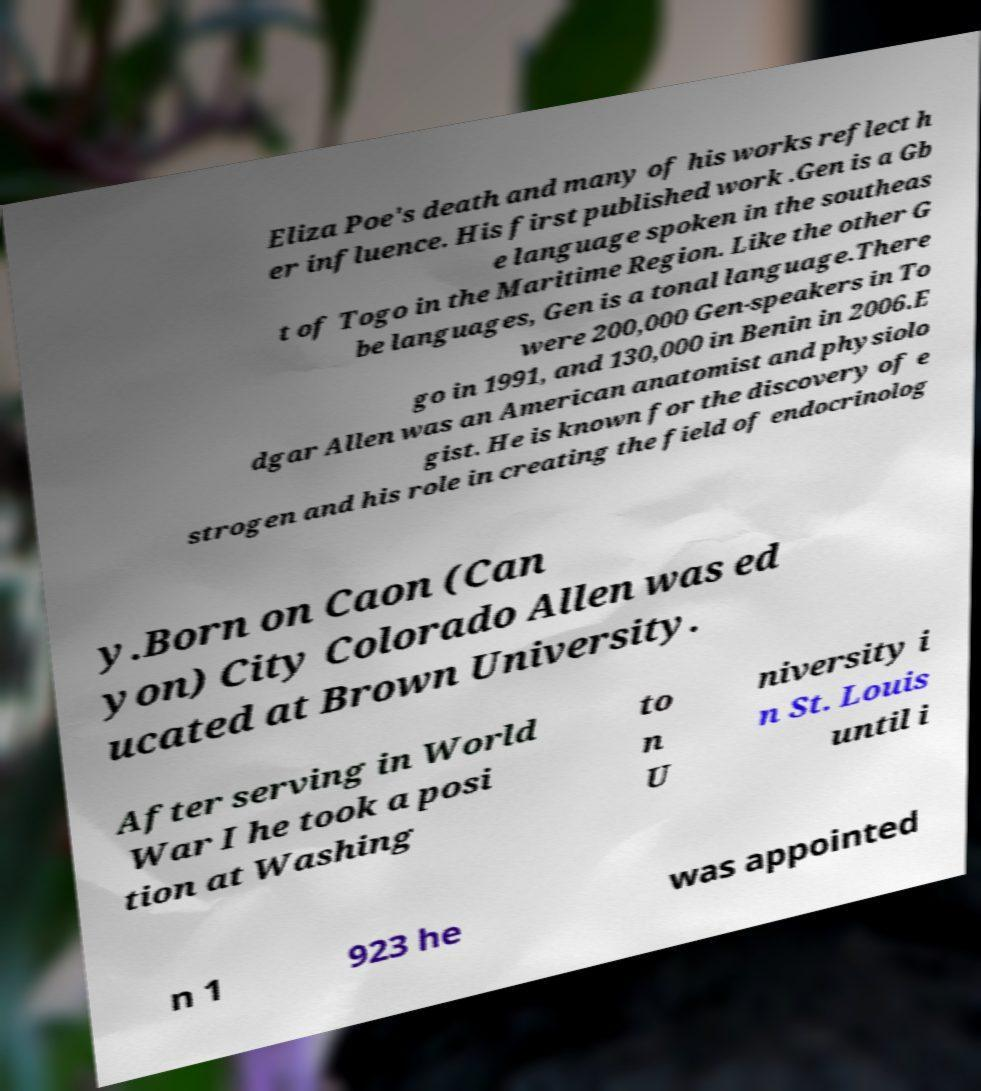Can you read and provide the text displayed in the image?This photo seems to have some interesting text. Can you extract and type it out for me? Eliza Poe's death and many of his works reflect h er influence. His first published work .Gen is a Gb e language spoken in the southeas t of Togo in the Maritime Region. Like the other G be languages, Gen is a tonal language.There were 200,000 Gen-speakers in To go in 1991, and 130,000 in Benin in 2006.E dgar Allen was an American anatomist and physiolo gist. He is known for the discovery of e strogen and his role in creating the field of endocrinolog y.Born on Caon (Can yon) City Colorado Allen was ed ucated at Brown University. After serving in World War I he took a posi tion at Washing to n U niversity i n St. Louis until i n 1 923 he was appointed 